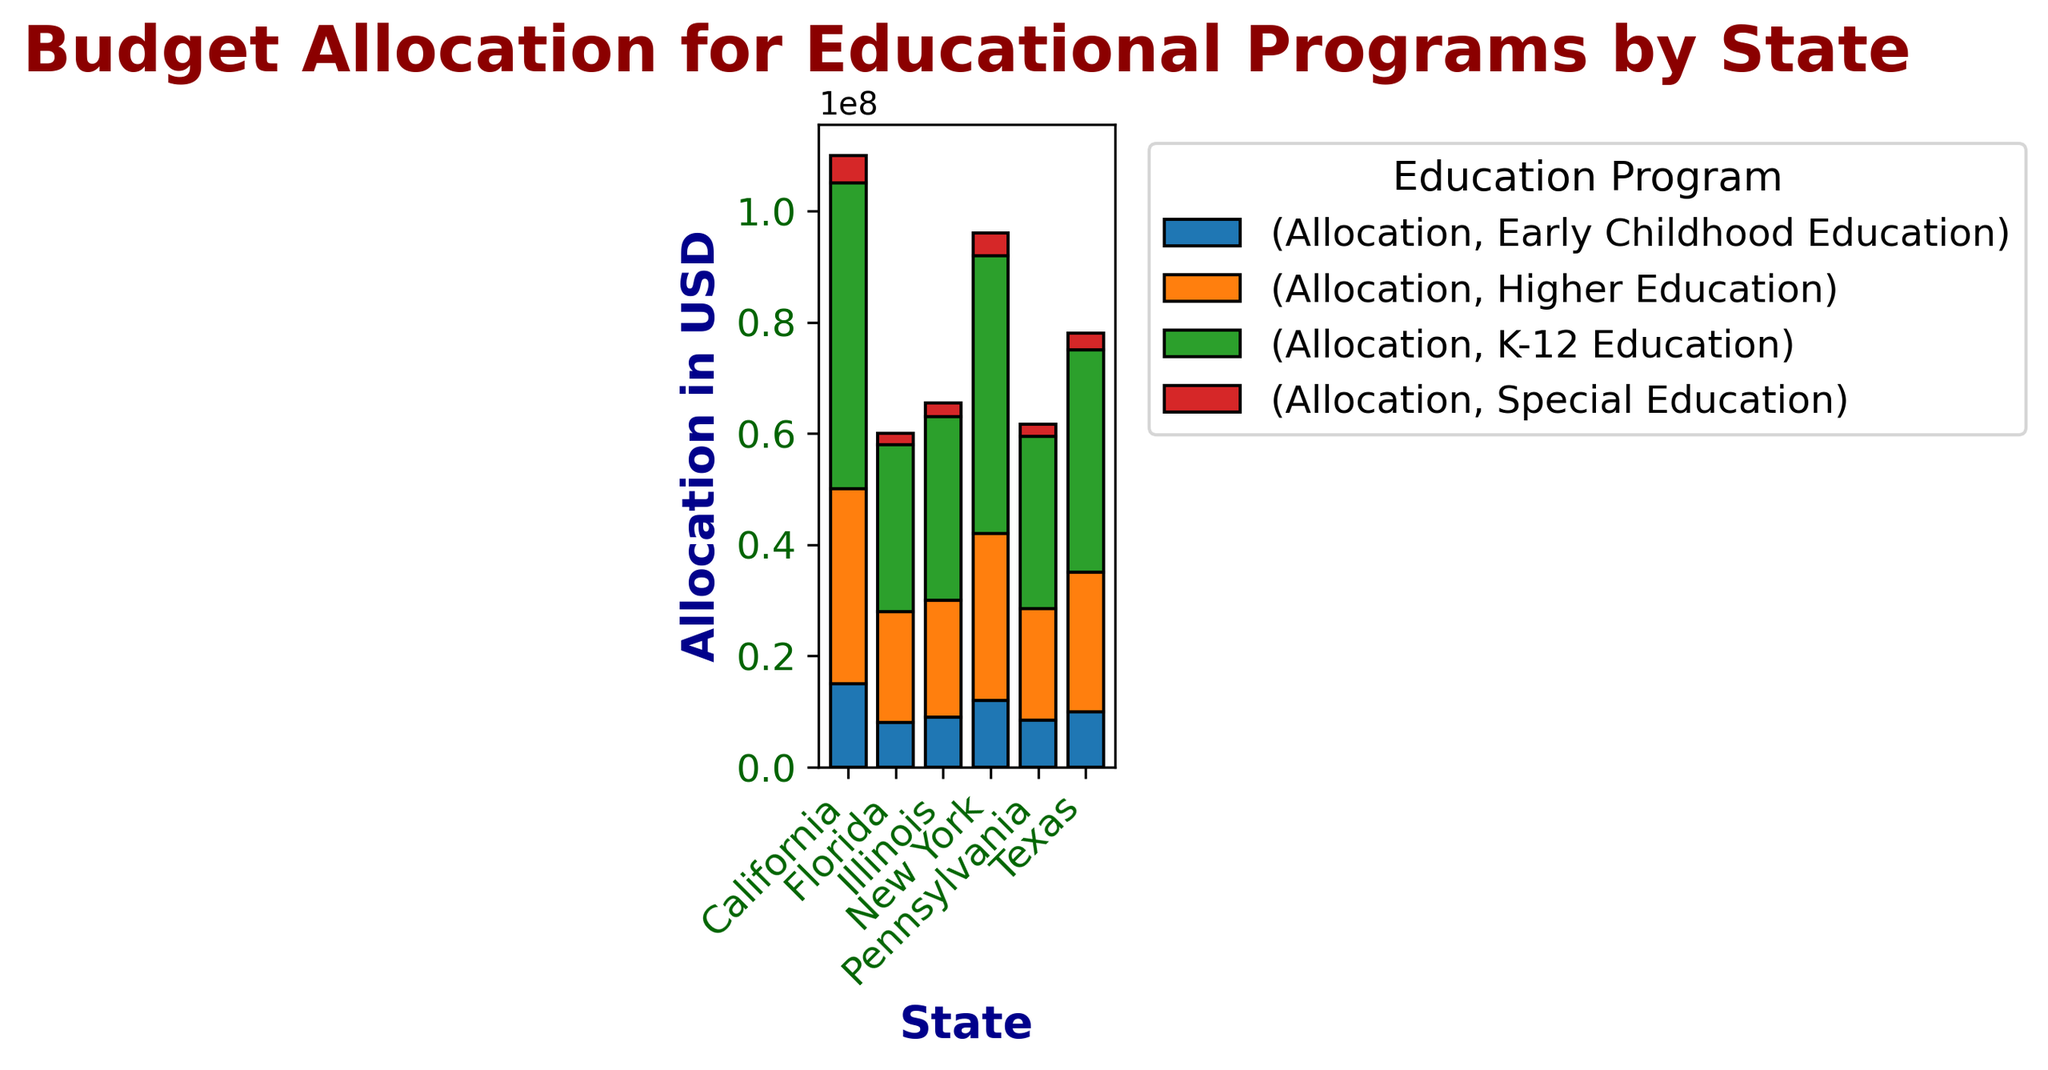What state allocated the highest budget to K-12 Education? To determine which state allocated the highest budget to K-12 Education, look at the heights of the K-12 Education bars. California's K-12 Education bar is the highest with an allocation of $55,000,000.
Answer: California Which educational program in Texas received the lowest budget allocation? To find the lowest allocation for Texas, look at the smallest bar in Texas's segment. The Special Education program in Texas has the smallest allocation which is $3,000,000.
Answer: Special Education What is the total budget allocation for all educational programs in New York? Sum the heights of all bars for New York: K-12 Education $50,000,000 + Higher Education $30,000,000 + Early Childhood Education $12,000,000 + Special Education $4,000,000 equals $96,000,000.
Answer: $96,000,000 Compare the budget for Higher Education in California and Florida. Which state allocated more? Compare the heights of the Higher Education bars for California and Florida. California allocated $35,000,000, while Florida allocated $20,000,000. Therefore, California allocated more.
Answer: California What is the difference in allocation between Early Childhood Education and Special Education in Illinois? To find the difference, subtract the allocation of Special Education ($2,500,000) from Early Childhood Education ($9,000,000) for Illinois. $9,000,000 - $2,500,000 equals $6,500,000.
Answer: $6,500,000 What is the average budget allocation for Higher Education across all states? First, find the total allocation for Higher Education across all states: ($35,000,000 + $25,000,000 + $30,000,000 + $20,000,000 + $21,000,000 + $20,000,000) equals $151,000,000 and then divide by the number of states (6). $151,000,000 / 6 equals approximately $25,166,667.
Answer: $25,166,667 Which state has the smallest total allocation for educational programs? Sum the heights of all bars for each state and compare. Florida has the smallest total allocation. K-12 Education $30,000,000 + Higher Education $20,000,000 + Early Childhood Education $8,000,000 + Special Education $2,000,000 equals $60,000,000.
Answer: Florida How does the allocation for Early Childhood Education in Pennsylvania compare to that in California? Compare the heights of the Early Childhood Education bars for Pennsylvania and California. Pennsylvania allocated $8,500,000, while California allocated $15,000,000. Therefore, Pennsylvania's allocation is lower.
Answer: Pennsylvania's allocation is lower 